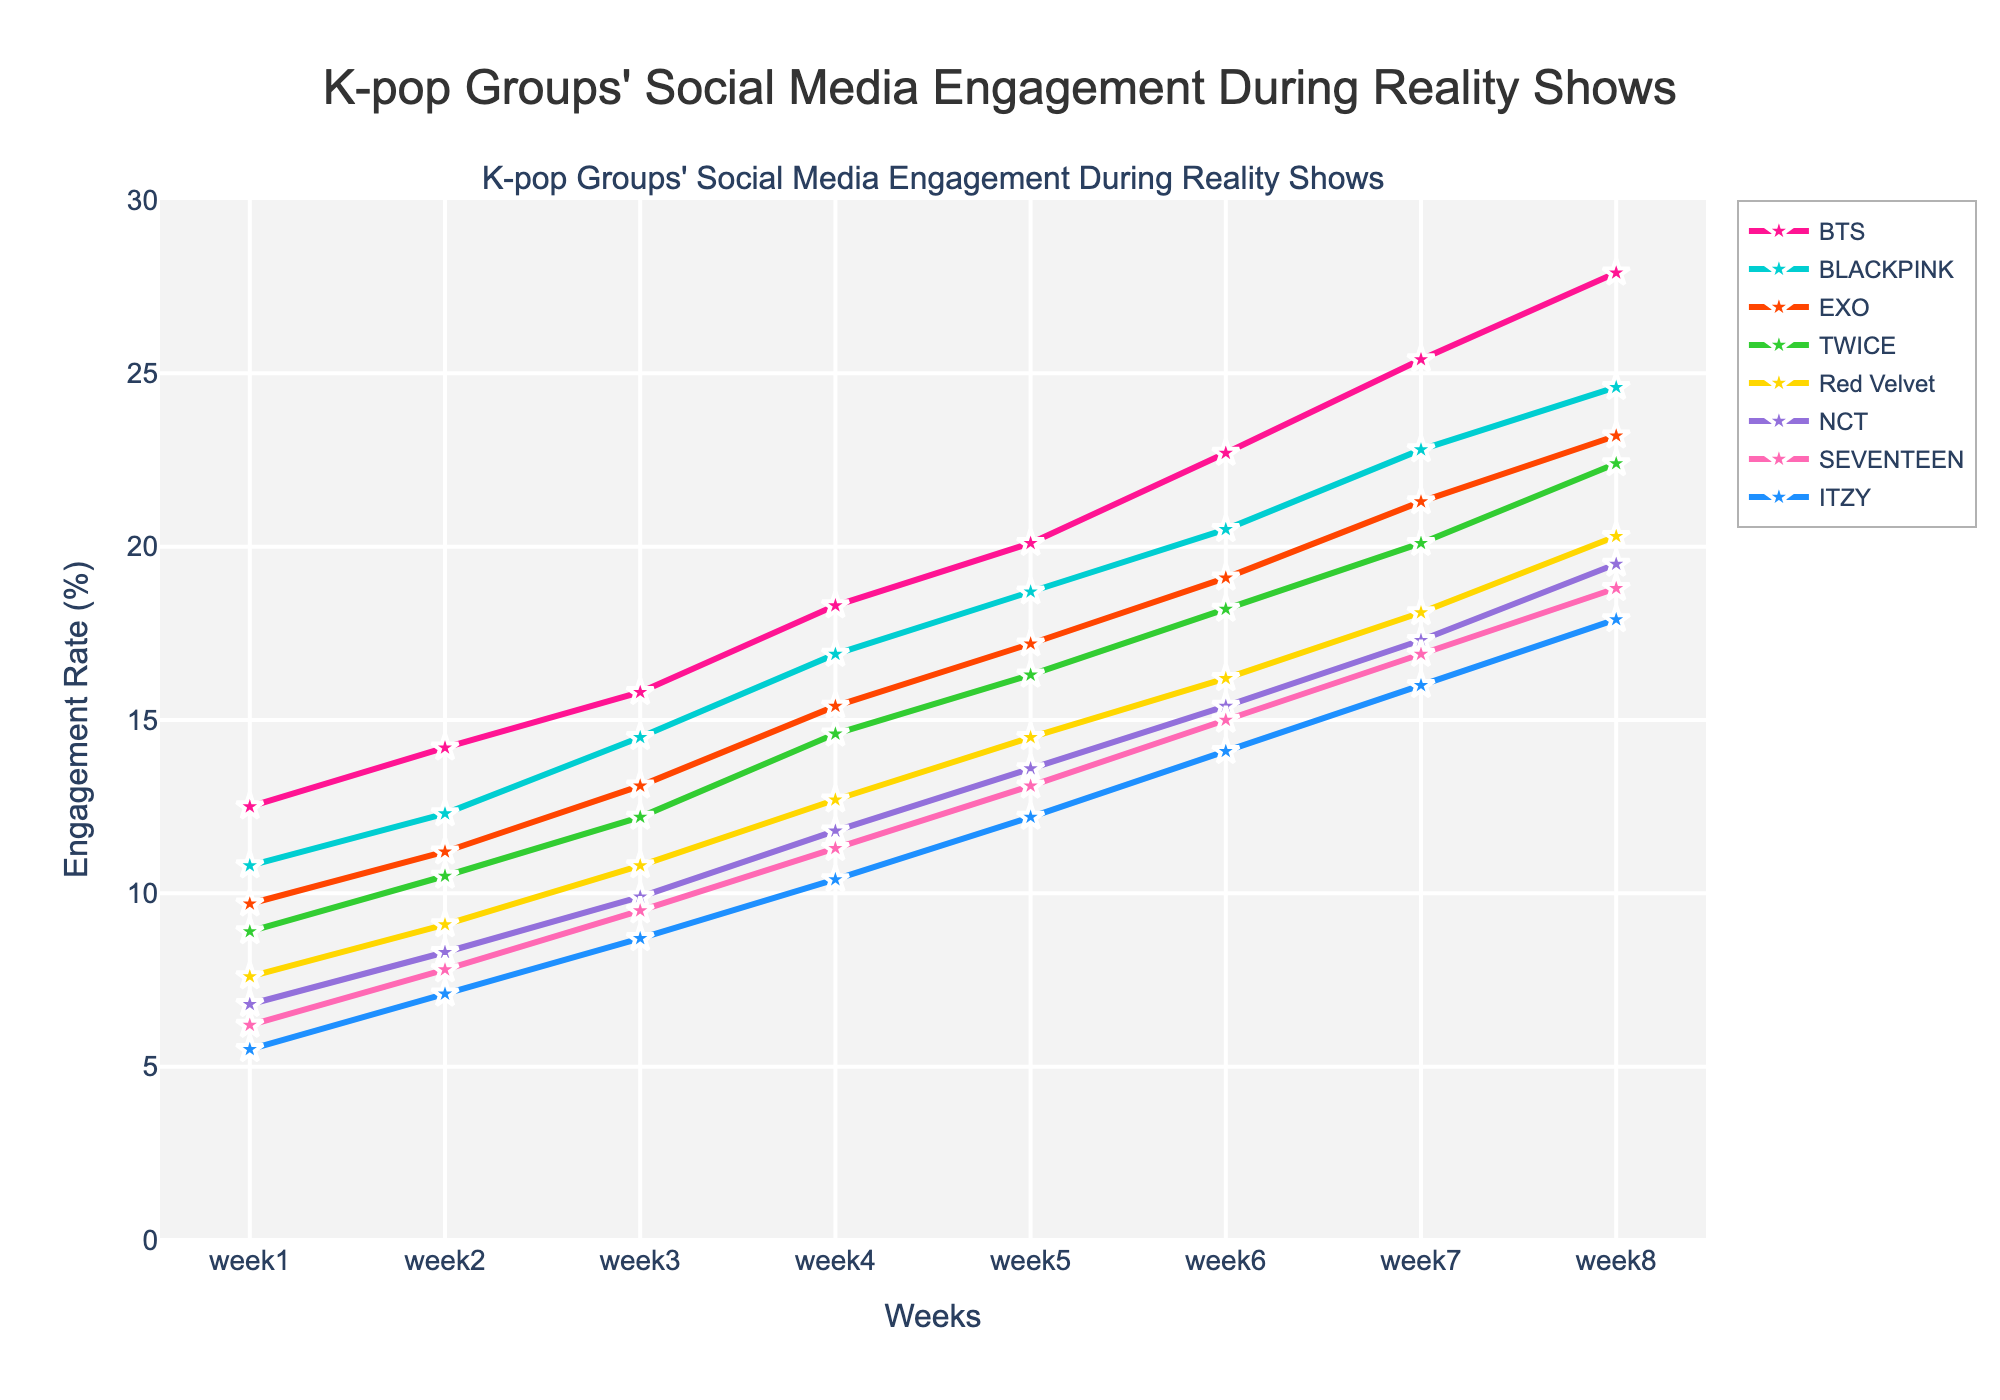What's the trend in social media engagement rates over the weeks for BTS? BTS shows a continuous increase in social media engagement rates from week 1 to week 8. Starting at 12.5% in week 1, it steadily increased, reaching 27.9% by week 8.
Answer: Continuous increase, starting at 12.5% and ending at 27.9% Which group had the highest engagement rate in week 4, and what was it? In week 4, BTS had the highest engagement rate. The visual representation shows that BTS's line is the highest among all groups during this week, with an engagement rate of 18.3%.
Answer: BTS, 18.3% By how much did EXO's engagement rate increase from week 5 to week 7? EXO's engagement rate in week 5 was 17.2%, and by week 7, it increased to 21.3%. The difference is calculated by subtracting the week 5 rate from the week 7 rate: 21.3% - 17.2% = 4.1%.
Answer: 4.1% Compare the engagement rates of BLACKPINK and TWICE in week 8. Which group had the higher rate and by how much? In week 8, BLACKPINK had an engagement rate of 24.6%, and TWICE had 22.4%. BLACKPINK's rate was higher by comparing 24.6% and 22.4%. The difference is 24.6% - 22.4% = 2.2%.
Answer: BLACKPINK, 2.2% Which group had the lowest starting engagement rate, and what was it? ITZY had the lowest starting engagement rate in week 1. This is apparent as their line starts lower than the others, with an engagement rate of 5.5%.
Answer: ITZY, 5.5% What is the overall average engagement rate across all groups in week 7? Sum the engagement rates of all groups in week 7: (25.4 + 22.8 + 21.3 + 20.1 + 18.1 + 17.3 + 16.9 + 16.0) = 158.9. There are 8 groups, so the average rate is 158.9 / 8 = 19.86%.
Answer: 19.86% How does the engagement trend of NCT compare to SEVENTEEN over the 8 weeks? Both NCT and SEVENTEEN show an upward trend in engagement rates. NCT starts at 6.8% and ends at 19.5%, while SEVENTEEN starts at 6.2% and ends at 18.8%. NCT's trend line is slightly steeper, indicating a faster rate of increase.
Answer: Both increasing, NCT's increase is faster What can be observed about Red Velvet's engagement rate growth compared to ITZY's? From week 1 to week 8, Red Velvet's engagement rate grows from 7.6% to 20.3%, while ITZY's grows from 5.5% to 17.9%. Red Velvet consistently shows higher engagement growth than ITZY throughout the weeks.
Answer: Red Velvet consistently higher What's the difference in engagement rate increase from week 1 to week 8 for the group with the highest growth and the one with the lowest growth? BTS has the highest increase (27.9% - 12.5% = 15.4%) and ITZY the lowest (17.9% - 5.5% = 12.4%). The difference in increase is 15.4% - 12.4% = 3%.
Answer: 3% Which group’s engagement rate in week 6 is closest to 20%? In week 6, the engagement rates are BTS (22.7%), BLACKPINK (20.5%), EXO (19.1%), TWICE (18.2%), Red Velvet (16.2%), NCT (15.4%), SEVENTEEN (15.0%), and ITZY (14.1%). BLACKPINK's engagement rate of 20.5% is closest to 20%.
Answer: BLACKPINK 